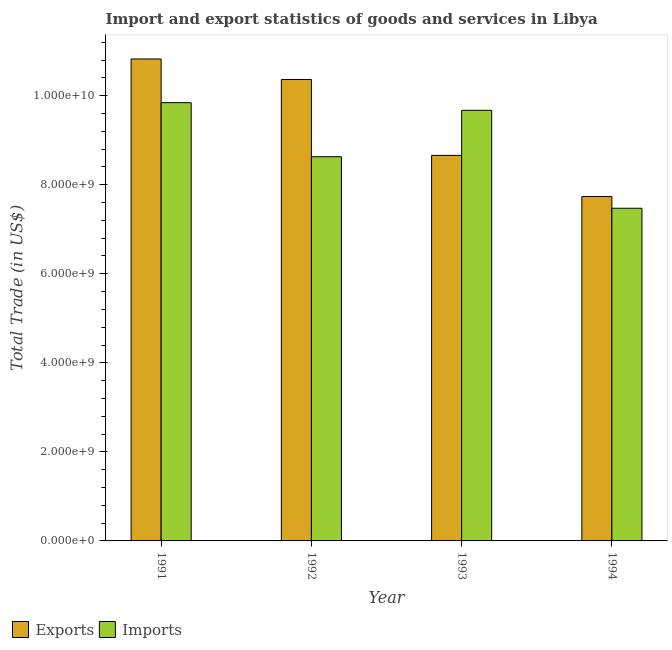How many different coloured bars are there?
Make the answer very short. 2. How many groups of bars are there?
Keep it short and to the point. 4. How many bars are there on the 3rd tick from the left?
Ensure brevity in your answer.  2. How many bars are there on the 2nd tick from the right?
Make the answer very short. 2. What is the label of the 3rd group of bars from the left?
Provide a succinct answer. 1993. What is the export of goods and services in 1993?
Provide a short and direct response. 8.66e+09. Across all years, what is the maximum imports of goods and services?
Your response must be concise. 9.84e+09. Across all years, what is the minimum imports of goods and services?
Offer a terse response. 7.47e+09. In which year was the export of goods and services minimum?
Your response must be concise. 1994. What is the total imports of goods and services in the graph?
Make the answer very short. 3.56e+1. What is the difference between the export of goods and services in 1991 and that in 1992?
Your answer should be very brief. 4.60e+08. What is the difference between the export of goods and services in 1994 and the imports of goods and services in 1993?
Provide a succinct answer. -9.25e+08. What is the average imports of goods and services per year?
Your answer should be compact. 8.90e+09. What is the ratio of the export of goods and services in 1993 to that in 1994?
Your answer should be very brief. 1.12. Is the imports of goods and services in 1992 less than that in 1993?
Your answer should be very brief. Yes. Is the difference between the export of goods and services in 1993 and 1994 greater than the difference between the imports of goods and services in 1993 and 1994?
Your answer should be very brief. No. What is the difference between the highest and the second highest export of goods and services?
Make the answer very short. 4.60e+08. What is the difference between the highest and the lowest imports of goods and services?
Offer a terse response. 2.37e+09. In how many years, is the export of goods and services greater than the average export of goods and services taken over all years?
Keep it short and to the point. 2. What does the 1st bar from the left in 1991 represents?
Keep it short and to the point. Exports. What does the 2nd bar from the right in 1992 represents?
Offer a very short reply. Exports. Are all the bars in the graph horizontal?
Provide a succinct answer. No. What is the difference between two consecutive major ticks on the Y-axis?
Make the answer very short. 2.00e+09. Does the graph contain any zero values?
Your answer should be very brief. No. Where does the legend appear in the graph?
Keep it short and to the point. Bottom left. How many legend labels are there?
Your answer should be very brief. 2. How are the legend labels stacked?
Your response must be concise. Horizontal. What is the title of the graph?
Keep it short and to the point. Import and export statistics of goods and services in Libya. What is the label or title of the Y-axis?
Make the answer very short. Total Trade (in US$). What is the Total Trade (in US$) of Exports in 1991?
Make the answer very short. 1.08e+1. What is the Total Trade (in US$) of Imports in 1991?
Provide a succinct answer. 9.84e+09. What is the Total Trade (in US$) of Exports in 1992?
Your answer should be very brief. 1.04e+1. What is the Total Trade (in US$) in Imports in 1992?
Your answer should be very brief. 8.63e+09. What is the Total Trade (in US$) of Exports in 1993?
Offer a very short reply. 8.66e+09. What is the Total Trade (in US$) in Imports in 1993?
Provide a succinct answer. 9.67e+09. What is the Total Trade (in US$) in Exports in 1994?
Provide a succinct answer. 7.73e+09. What is the Total Trade (in US$) of Imports in 1994?
Offer a terse response. 7.47e+09. Across all years, what is the maximum Total Trade (in US$) in Exports?
Offer a terse response. 1.08e+1. Across all years, what is the maximum Total Trade (in US$) in Imports?
Your response must be concise. 9.84e+09. Across all years, what is the minimum Total Trade (in US$) in Exports?
Provide a short and direct response. 7.73e+09. Across all years, what is the minimum Total Trade (in US$) of Imports?
Offer a very short reply. 7.47e+09. What is the total Total Trade (in US$) in Exports in the graph?
Your answer should be compact. 3.76e+1. What is the total Total Trade (in US$) of Imports in the graph?
Offer a terse response. 3.56e+1. What is the difference between the Total Trade (in US$) of Exports in 1991 and that in 1992?
Make the answer very short. 4.60e+08. What is the difference between the Total Trade (in US$) of Imports in 1991 and that in 1992?
Your answer should be very brief. 1.21e+09. What is the difference between the Total Trade (in US$) in Exports in 1991 and that in 1993?
Your answer should be very brief. 2.17e+09. What is the difference between the Total Trade (in US$) in Imports in 1991 and that in 1993?
Your answer should be very brief. 1.72e+08. What is the difference between the Total Trade (in US$) in Exports in 1991 and that in 1994?
Provide a short and direct response. 3.09e+09. What is the difference between the Total Trade (in US$) in Imports in 1991 and that in 1994?
Your answer should be very brief. 2.37e+09. What is the difference between the Total Trade (in US$) of Exports in 1992 and that in 1993?
Keep it short and to the point. 1.70e+09. What is the difference between the Total Trade (in US$) of Imports in 1992 and that in 1993?
Provide a succinct answer. -1.04e+09. What is the difference between the Total Trade (in US$) in Exports in 1992 and that in 1994?
Ensure brevity in your answer.  2.63e+09. What is the difference between the Total Trade (in US$) of Imports in 1992 and that in 1994?
Your response must be concise. 1.16e+09. What is the difference between the Total Trade (in US$) of Exports in 1993 and that in 1994?
Your response must be concise. 9.25e+08. What is the difference between the Total Trade (in US$) of Imports in 1993 and that in 1994?
Make the answer very short. 2.20e+09. What is the difference between the Total Trade (in US$) of Exports in 1991 and the Total Trade (in US$) of Imports in 1992?
Keep it short and to the point. 2.20e+09. What is the difference between the Total Trade (in US$) of Exports in 1991 and the Total Trade (in US$) of Imports in 1993?
Ensure brevity in your answer.  1.15e+09. What is the difference between the Total Trade (in US$) in Exports in 1991 and the Total Trade (in US$) in Imports in 1994?
Keep it short and to the point. 3.35e+09. What is the difference between the Total Trade (in US$) of Exports in 1992 and the Total Trade (in US$) of Imports in 1993?
Offer a terse response. 6.93e+08. What is the difference between the Total Trade (in US$) in Exports in 1992 and the Total Trade (in US$) in Imports in 1994?
Your response must be concise. 2.89e+09. What is the difference between the Total Trade (in US$) in Exports in 1993 and the Total Trade (in US$) in Imports in 1994?
Ensure brevity in your answer.  1.19e+09. What is the average Total Trade (in US$) of Exports per year?
Your answer should be very brief. 9.40e+09. What is the average Total Trade (in US$) in Imports per year?
Provide a short and direct response. 8.90e+09. In the year 1991, what is the difference between the Total Trade (in US$) in Exports and Total Trade (in US$) in Imports?
Ensure brevity in your answer.  9.81e+08. In the year 1992, what is the difference between the Total Trade (in US$) of Exports and Total Trade (in US$) of Imports?
Offer a very short reply. 1.73e+09. In the year 1993, what is the difference between the Total Trade (in US$) in Exports and Total Trade (in US$) in Imports?
Offer a terse response. -1.01e+09. In the year 1994, what is the difference between the Total Trade (in US$) in Exports and Total Trade (in US$) in Imports?
Make the answer very short. 2.63e+08. What is the ratio of the Total Trade (in US$) in Exports in 1991 to that in 1992?
Keep it short and to the point. 1.04. What is the ratio of the Total Trade (in US$) in Imports in 1991 to that in 1992?
Make the answer very short. 1.14. What is the ratio of the Total Trade (in US$) of Exports in 1991 to that in 1993?
Your response must be concise. 1.25. What is the ratio of the Total Trade (in US$) in Imports in 1991 to that in 1993?
Make the answer very short. 1.02. What is the ratio of the Total Trade (in US$) of Exports in 1991 to that in 1994?
Provide a short and direct response. 1.4. What is the ratio of the Total Trade (in US$) in Imports in 1991 to that in 1994?
Provide a succinct answer. 1.32. What is the ratio of the Total Trade (in US$) in Exports in 1992 to that in 1993?
Give a very brief answer. 1.2. What is the ratio of the Total Trade (in US$) in Imports in 1992 to that in 1993?
Provide a short and direct response. 0.89. What is the ratio of the Total Trade (in US$) of Exports in 1992 to that in 1994?
Offer a terse response. 1.34. What is the ratio of the Total Trade (in US$) in Imports in 1992 to that in 1994?
Offer a terse response. 1.15. What is the ratio of the Total Trade (in US$) of Exports in 1993 to that in 1994?
Your answer should be very brief. 1.12. What is the ratio of the Total Trade (in US$) of Imports in 1993 to that in 1994?
Give a very brief answer. 1.29. What is the difference between the highest and the second highest Total Trade (in US$) in Exports?
Keep it short and to the point. 4.60e+08. What is the difference between the highest and the second highest Total Trade (in US$) of Imports?
Offer a very short reply. 1.72e+08. What is the difference between the highest and the lowest Total Trade (in US$) in Exports?
Make the answer very short. 3.09e+09. What is the difference between the highest and the lowest Total Trade (in US$) in Imports?
Make the answer very short. 2.37e+09. 